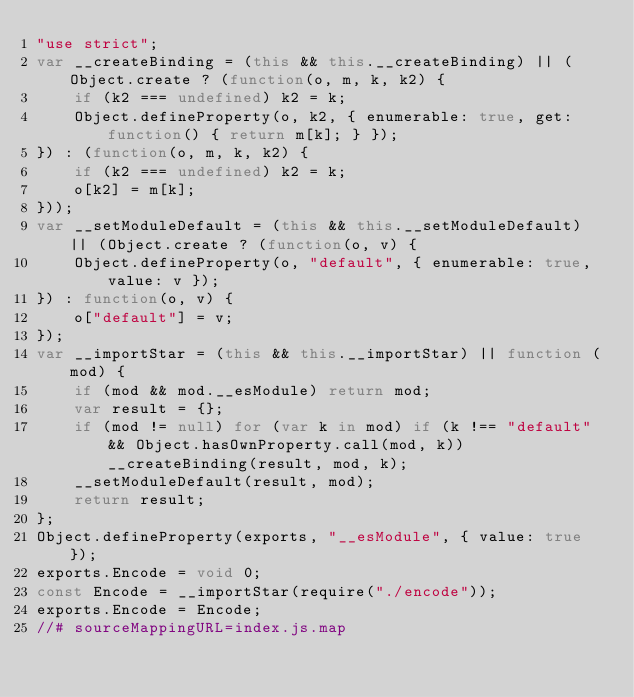Convert code to text. <code><loc_0><loc_0><loc_500><loc_500><_JavaScript_>"use strict";
var __createBinding = (this && this.__createBinding) || (Object.create ? (function(o, m, k, k2) {
    if (k2 === undefined) k2 = k;
    Object.defineProperty(o, k2, { enumerable: true, get: function() { return m[k]; } });
}) : (function(o, m, k, k2) {
    if (k2 === undefined) k2 = k;
    o[k2] = m[k];
}));
var __setModuleDefault = (this && this.__setModuleDefault) || (Object.create ? (function(o, v) {
    Object.defineProperty(o, "default", { enumerable: true, value: v });
}) : function(o, v) {
    o["default"] = v;
});
var __importStar = (this && this.__importStar) || function (mod) {
    if (mod && mod.__esModule) return mod;
    var result = {};
    if (mod != null) for (var k in mod) if (k !== "default" && Object.hasOwnProperty.call(mod, k)) __createBinding(result, mod, k);
    __setModuleDefault(result, mod);
    return result;
};
Object.defineProperty(exports, "__esModule", { value: true });
exports.Encode = void 0;
const Encode = __importStar(require("./encode"));
exports.Encode = Encode;
//# sourceMappingURL=index.js.map</code> 